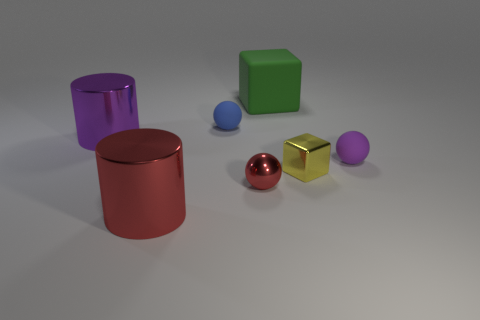Are there any metal balls of the same size as the yellow metallic cube?
Your answer should be very brief. Yes. Are there fewer purple cylinders that are on the right side of the tiny blue object than brown metal blocks?
Keep it short and to the point. No. Are there fewer large red cylinders to the left of the purple shiny object than small rubber objects right of the big green matte block?
Offer a terse response. Yes. What number of cylinders are yellow shiny objects or purple matte things?
Offer a terse response. 0. Does the ball on the left side of the tiny red sphere have the same material as the big thing in front of the yellow shiny thing?
Give a very brief answer. No. There is a purple object that is the same size as the yellow thing; what shape is it?
Your response must be concise. Sphere. What number of other things are the same color as the small shiny sphere?
Your answer should be very brief. 1. What number of cyan objects are big cylinders or rubber blocks?
Provide a short and direct response. 0. There is a tiny matte object in front of the big purple metal thing; is its shape the same as the small thing that is in front of the tiny metallic cube?
Give a very brief answer. Yes. What number of other objects are there of the same material as the purple sphere?
Make the answer very short. 2. 